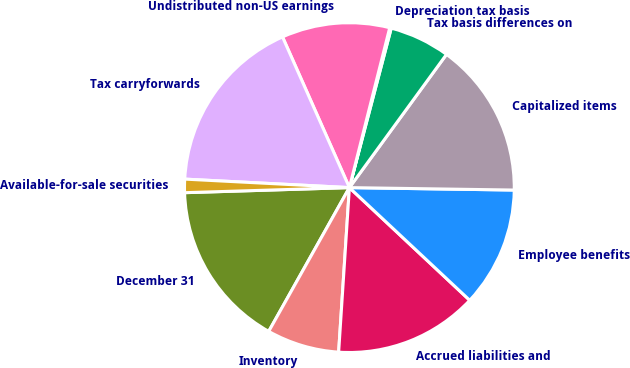Convert chart to OTSL. <chart><loc_0><loc_0><loc_500><loc_500><pie_chart><fcel>December 31<fcel>Inventory<fcel>Accrued liabilities and<fcel>Employee benefits<fcel>Capitalized items<fcel>Tax basis differences on<fcel>Depreciation tax basis<fcel>Undistributed non-US earnings<fcel>Tax carryforwards<fcel>Available-for-sale securities<nl><fcel>16.37%<fcel>7.1%<fcel>14.06%<fcel>11.74%<fcel>15.21%<fcel>5.94%<fcel>0.15%<fcel>10.58%<fcel>17.53%<fcel>1.31%<nl></chart> 